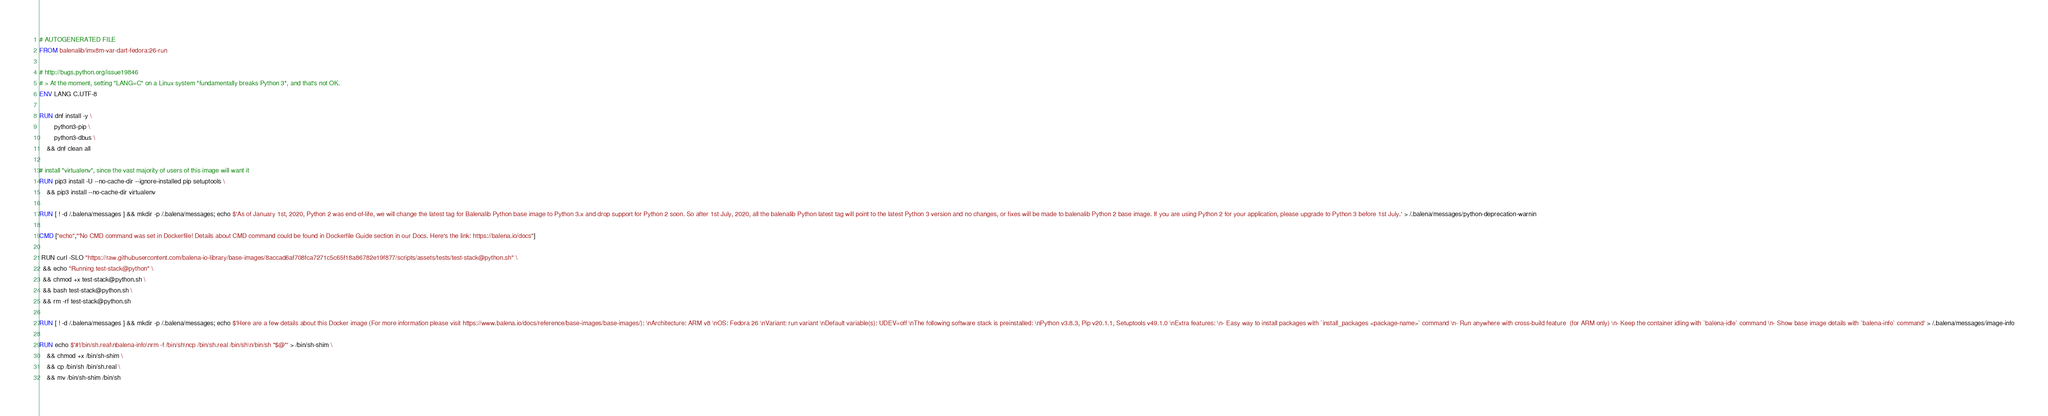Convert code to text. <code><loc_0><loc_0><loc_500><loc_500><_Dockerfile_># AUTOGENERATED FILE
FROM balenalib/imx8m-var-dart-fedora:26-run

# http://bugs.python.org/issue19846
# > At the moment, setting "LANG=C" on a Linux system *fundamentally breaks Python 3*, and that's not OK.
ENV LANG C.UTF-8

RUN dnf install -y \
		python3-pip \
		python3-dbus \
	&& dnf clean all

# install "virtualenv", since the vast majority of users of this image will want it
RUN pip3 install -U --no-cache-dir --ignore-installed pip setuptools \
	&& pip3 install --no-cache-dir virtualenv

RUN [ ! -d /.balena/messages ] && mkdir -p /.balena/messages; echo $'As of January 1st, 2020, Python 2 was end-of-life, we will change the latest tag for Balenalib Python base image to Python 3.x and drop support for Python 2 soon. So after 1st July, 2020, all the balenalib Python latest tag will point to the latest Python 3 version and no changes, or fixes will be made to balenalib Python 2 base image. If you are using Python 2 for your application, please upgrade to Python 3 before 1st July.' > /.balena/messages/python-deprecation-warnin

CMD ["echo","'No CMD command was set in Dockerfile! Details about CMD command could be found in Dockerfile Guide section in our Docs. Here's the link: https://balena.io/docs"]

 RUN curl -SLO "https://raw.githubusercontent.com/balena-io-library/base-images/8accad6af708fca7271c5c65f18a86782e19f877/scripts/assets/tests/test-stack@python.sh" \
  && echo "Running test-stack@python" \
  && chmod +x test-stack@python.sh \
  && bash test-stack@python.sh \
  && rm -rf test-stack@python.sh 

RUN [ ! -d /.balena/messages ] && mkdir -p /.balena/messages; echo $'Here are a few details about this Docker image (For more information please visit https://www.balena.io/docs/reference/base-images/base-images/): \nArchitecture: ARM v8 \nOS: Fedora 26 \nVariant: run variant \nDefault variable(s): UDEV=off \nThe following software stack is preinstalled: \nPython v3.8.3, Pip v20.1.1, Setuptools v49.1.0 \nExtra features: \n- Easy way to install packages with `install_packages <package-name>` command \n- Run anywhere with cross-build feature  (for ARM only) \n- Keep the container idling with `balena-idle` command \n- Show base image details with `balena-info` command' > /.balena/messages/image-info

RUN echo $'#!/bin/sh.real\nbalena-info\nrm -f /bin/sh\ncp /bin/sh.real /bin/sh\n/bin/sh "$@"' > /bin/sh-shim \
	&& chmod +x /bin/sh-shim \
	&& cp /bin/sh /bin/sh.real \
	&& mv /bin/sh-shim /bin/sh</code> 